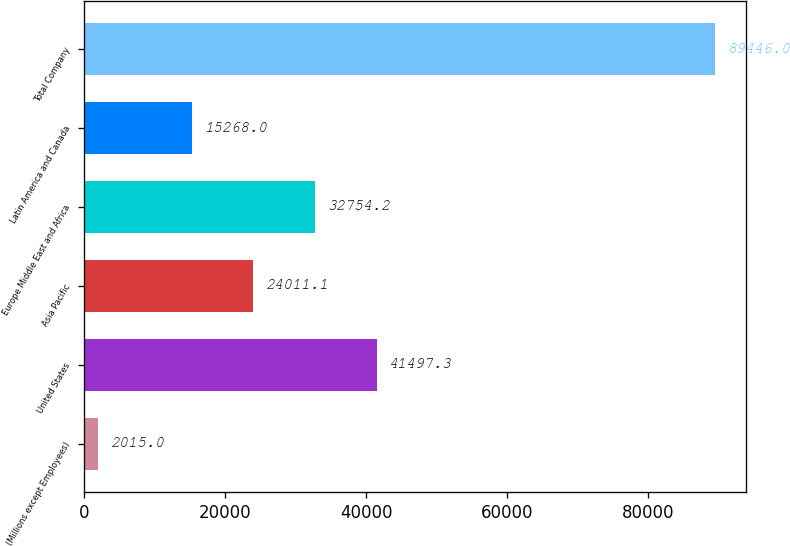Convert chart. <chart><loc_0><loc_0><loc_500><loc_500><bar_chart><fcel>(Millions except Employees)<fcel>United States<fcel>Asia Pacific<fcel>Europe Middle East and Africa<fcel>Latin America and Canada<fcel>Total Company<nl><fcel>2015<fcel>41497.3<fcel>24011.1<fcel>32754.2<fcel>15268<fcel>89446<nl></chart> 